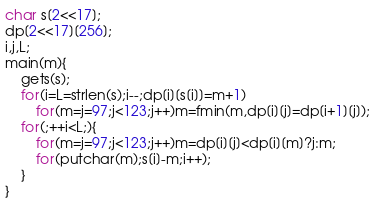<code> <loc_0><loc_0><loc_500><loc_500><_C_>char s[2<<17];
dp[2<<17][256];
i,j,L;
main(m){
	gets(s);
	for(i=L=strlen(s);i--;dp[i][s[i]]=m+1)
		for(m=j=97;j<123;j++)m=fmin(m,dp[i][j]=dp[i+1][j]);
	for(;++i<L;){
		for(m=j=97;j<123;j++)m=dp[i][j]<dp[i][m]?j:m;
		for(putchar(m);s[i]-m;i++);
	}
}</code> 